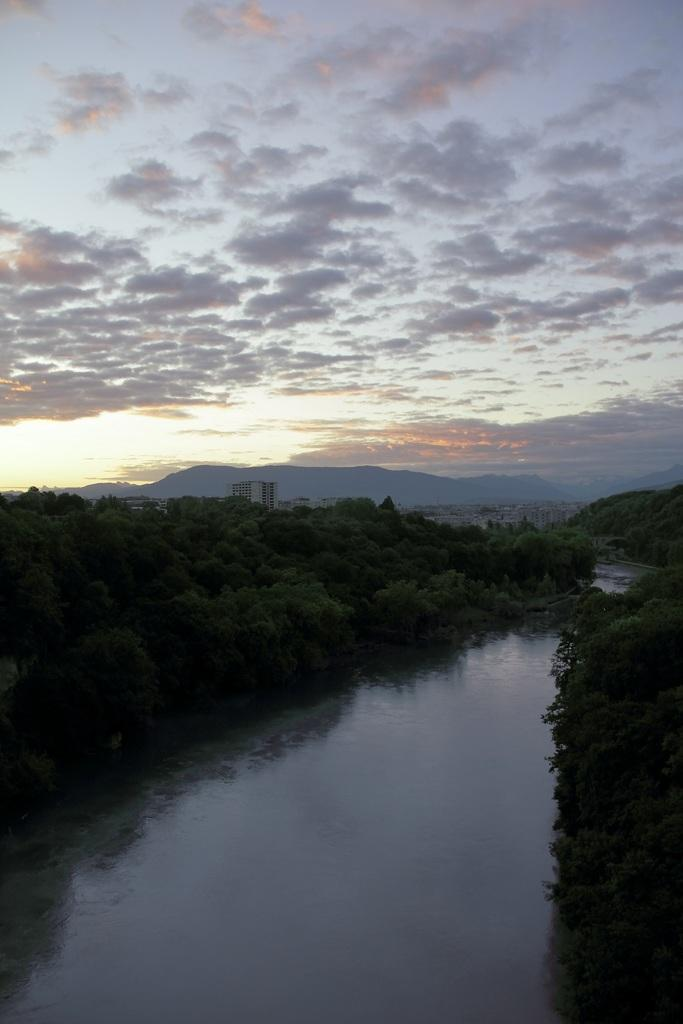What type of body of water is present in the image? There is a small water lake in the image. What surrounds the lake on both sides? There are many trees on both sides of the lake. What can be seen in the distance behind the lake? There is a mountain in the background of the image. How would you describe the sky in the image? The sky is clear and blue in the background of the image. What type of texture can be seen on the tub in the image? There is no tub present in the image; it features a small water lake, trees, a mountain, and a clear blue sky. 